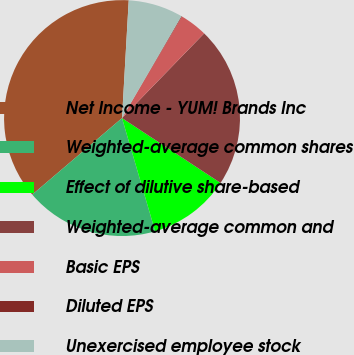<chart> <loc_0><loc_0><loc_500><loc_500><pie_chart><fcel>Net Income - YUM! Brands Inc<fcel>Weighted-average common shares<fcel>Effect of dilutive share-based<fcel>Weighted-average common and<fcel>Basic EPS<fcel>Diluted EPS<fcel>Unexercised employee stock<nl><fcel>37.14%<fcel>18.3%<fcel>11.2%<fcel>22.01%<fcel>3.78%<fcel>0.08%<fcel>7.49%<nl></chart> 